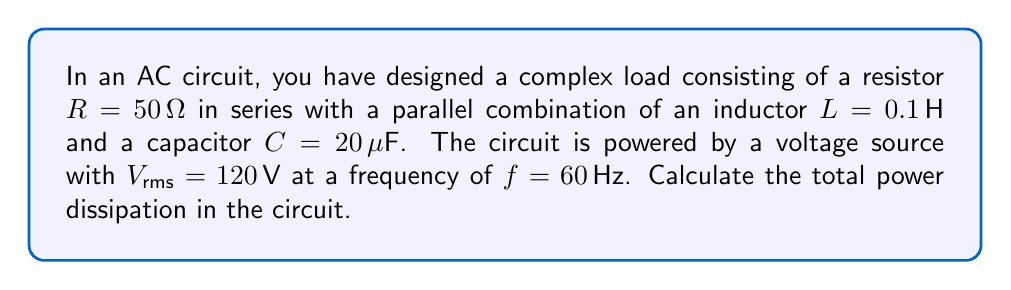Help me with this question. To solve this problem, we'll follow these steps:

1) First, calculate the angular frequency:
   $\omega = 2\pi f = 2\pi(60) = 377 \text{ rad/s}$

2) Calculate the reactances of the inductor and capacitor:
   $X_L = \omega L = 377(0.1) = 37.7 \Omega$
   $X_C = \frac{1}{\omega C} = \frac{1}{377(20 \times 10^{-6})} = 132.6 \Omega$

3) The impedance of the parallel LC combination is:
   $Z_{LC} = \frac{jX_L X_C}{X_C - X_L} = \frac{j(37.7)(132.6)}{132.6 - 37.7} = j50 \Omega$

4) The total impedance of the circuit is:
   $Z_{total} = R + Z_{LC} = 50 + j50 = 70.71 \angle 45^\circ \Omega$

5) Calculate the current in the circuit:
   $I_{rms} = \frac{V_{rms}}{|Z_{total}|} = \frac{120}{70.71} = 1.697 \text{ A}$

6) The power dissipation is given by:
   $P = I_{rms}^2 R = (1.697)^2(50) = 143.9 \text{ W}$

Thus, the total power dissipation in the circuit is approximately 143.9 W.
Answer: 143.9 W 